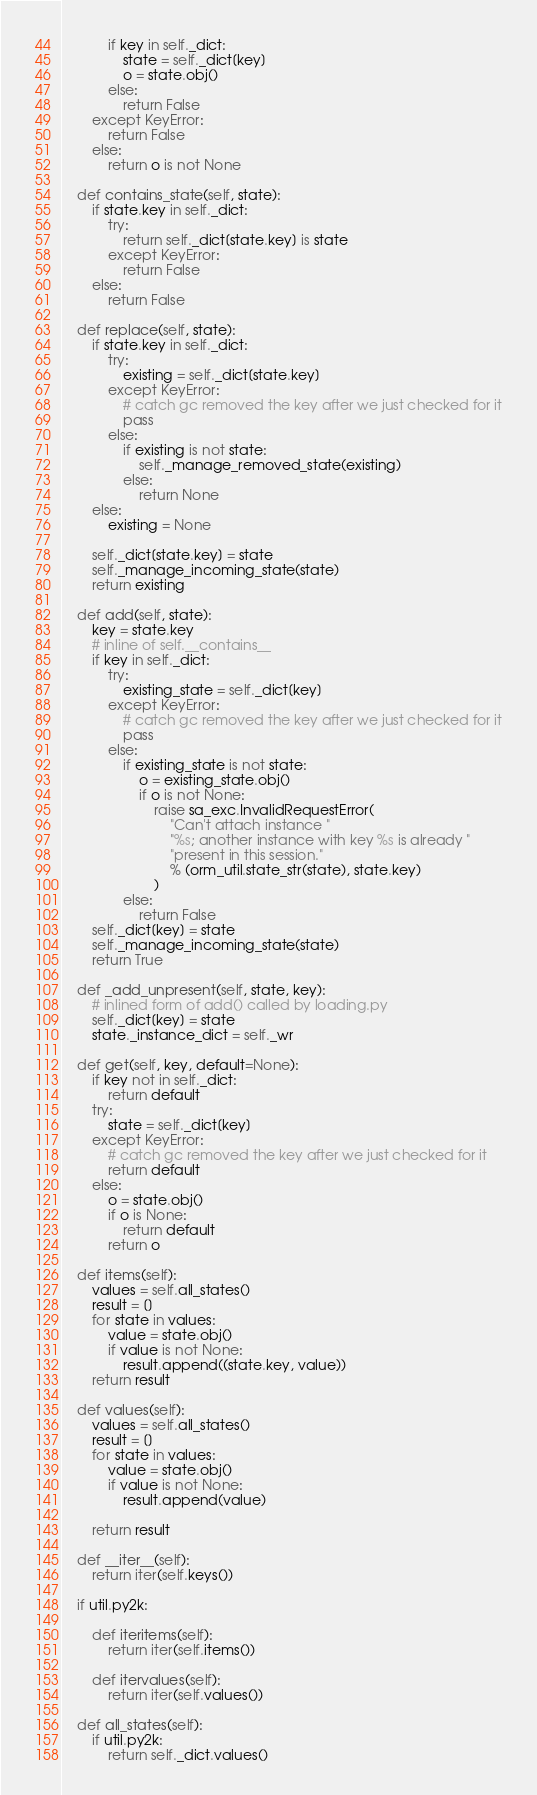<code> <loc_0><loc_0><loc_500><loc_500><_Python_>            if key in self._dict:
                state = self._dict[key]
                o = state.obj()
            else:
                return False
        except KeyError:
            return False
        else:
            return o is not None

    def contains_state(self, state):
        if state.key in self._dict:
            try:
                return self._dict[state.key] is state
            except KeyError:
                return False
        else:
            return False

    def replace(self, state):
        if state.key in self._dict:
            try:
                existing = self._dict[state.key]
            except KeyError:
                # catch gc removed the key after we just checked for it
                pass
            else:
                if existing is not state:
                    self._manage_removed_state(existing)
                else:
                    return None
        else:
            existing = None

        self._dict[state.key] = state
        self._manage_incoming_state(state)
        return existing

    def add(self, state):
        key = state.key
        # inline of self.__contains__
        if key in self._dict:
            try:
                existing_state = self._dict[key]
            except KeyError:
                # catch gc removed the key after we just checked for it
                pass
            else:
                if existing_state is not state:
                    o = existing_state.obj()
                    if o is not None:
                        raise sa_exc.InvalidRequestError(
                            "Can't attach instance "
                            "%s; another instance with key %s is already "
                            "present in this session."
                            % (orm_util.state_str(state), state.key)
                        )
                else:
                    return False
        self._dict[key] = state
        self._manage_incoming_state(state)
        return True

    def _add_unpresent(self, state, key):
        # inlined form of add() called by loading.py
        self._dict[key] = state
        state._instance_dict = self._wr

    def get(self, key, default=None):
        if key not in self._dict:
            return default
        try:
            state = self._dict[key]
        except KeyError:
            # catch gc removed the key after we just checked for it
            return default
        else:
            o = state.obj()
            if o is None:
                return default
            return o

    def items(self):
        values = self.all_states()
        result = []
        for state in values:
            value = state.obj()
            if value is not None:
                result.append((state.key, value))
        return result

    def values(self):
        values = self.all_states()
        result = []
        for state in values:
            value = state.obj()
            if value is not None:
                result.append(value)

        return result

    def __iter__(self):
        return iter(self.keys())

    if util.py2k:

        def iteritems(self):
            return iter(self.items())

        def itervalues(self):
            return iter(self.values())

    def all_states(self):
        if util.py2k:
            return self._dict.values()</code> 